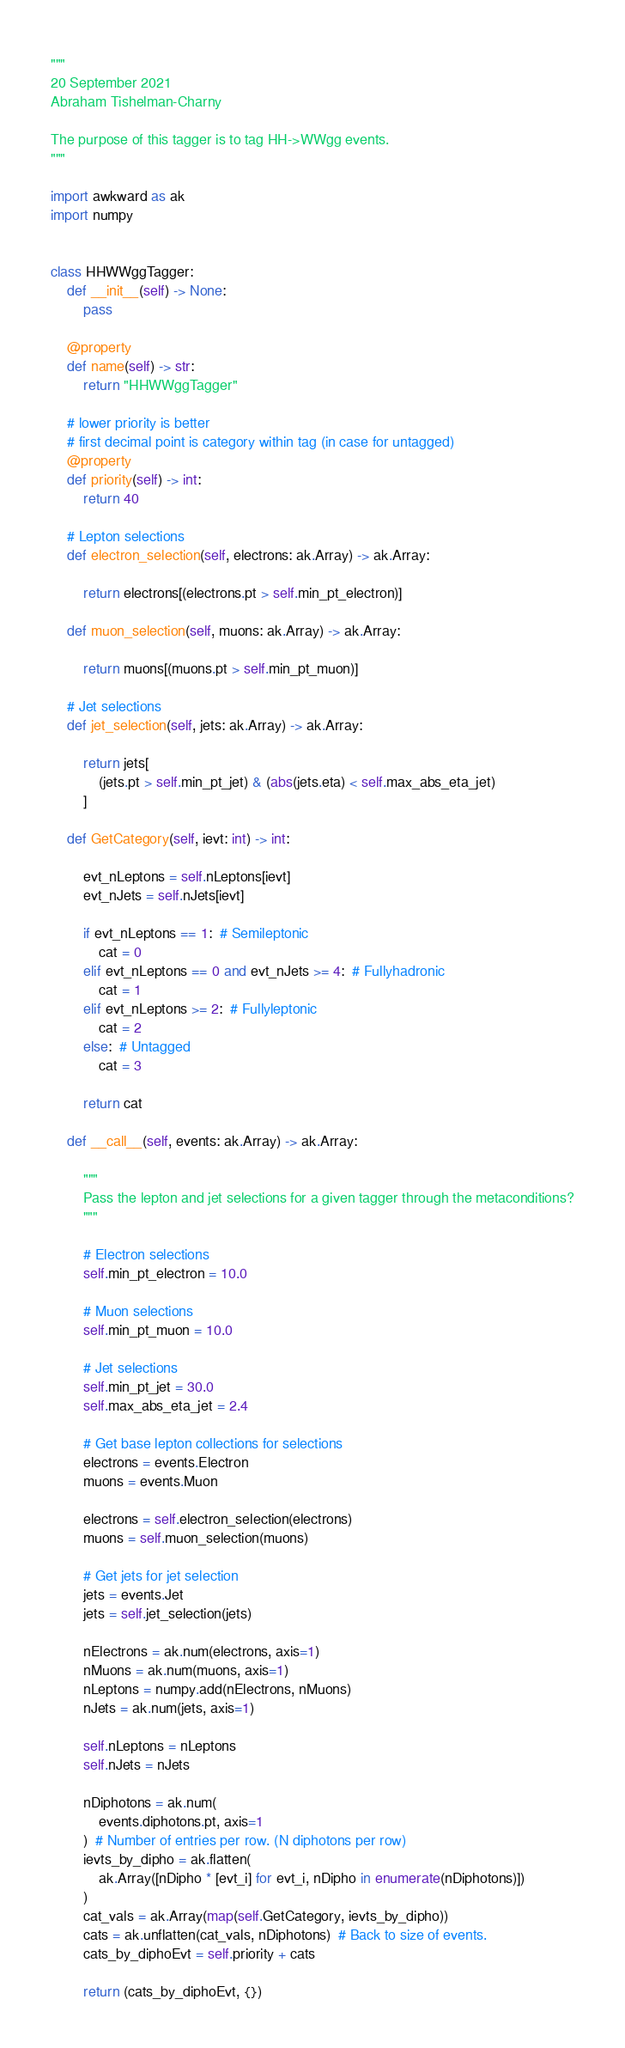Convert code to text. <code><loc_0><loc_0><loc_500><loc_500><_Python_>"""
20 September 2021
Abraham Tishelman-Charny

The purpose of this tagger is to tag HH->WWgg events.
"""

import awkward as ak
import numpy


class HHWWggTagger:
    def __init__(self) -> None:
        pass

    @property
    def name(self) -> str:
        return "HHWWggTagger"

    # lower priority is better
    # first decimal point is category within tag (in case for untagged)
    @property
    def priority(self) -> int:
        return 40

    # Lepton selections
    def electron_selection(self, electrons: ak.Array) -> ak.Array:

        return electrons[(electrons.pt > self.min_pt_electron)]

    def muon_selection(self, muons: ak.Array) -> ak.Array:

        return muons[(muons.pt > self.min_pt_muon)]

    # Jet selections
    def jet_selection(self, jets: ak.Array) -> ak.Array:

        return jets[
            (jets.pt > self.min_pt_jet) & (abs(jets.eta) < self.max_abs_eta_jet)
        ]

    def GetCategory(self, ievt: int) -> int:

        evt_nLeptons = self.nLeptons[ievt]
        evt_nJets = self.nJets[ievt]

        if evt_nLeptons == 1:  # Semileptonic
            cat = 0
        elif evt_nLeptons == 0 and evt_nJets >= 4:  # Fullyhadronic
            cat = 1
        elif evt_nLeptons >= 2:  # Fullyleptonic
            cat = 2
        else:  # Untagged
            cat = 3

        return cat

    def __call__(self, events: ak.Array) -> ak.Array:

        """
        Pass the lepton and jet selections for a given tagger through the metaconditions?
        """

        # Electron selections
        self.min_pt_electron = 10.0

        # Muon selections
        self.min_pt_muon = 10.0

        # Jet selections
        self.min_pt_jet = 30.0
        self.max_abs_eta_jet = 2.4

        # Get base lepton collections for selections
        electrons = events.Electron
        muons = events.Muon

        electrons = self.electron_selection(electrons)
        muons = self.muon_selection(muons)

        # Get jets for jet selection
        jets = events.Jet
        jets = self.jet_selection(jets)

        nElectrons = ak.num(electrons, axis=1)
        nMuons = ak.num(muons, axis=1)
        nLeptons = numpy.add(nElectrons, nMuons)
        nJets = ak.num(jets, axis=1)

        self.nLeptons = nLeptons
        self.nJets = nJets

        nDiphotons = ak.num(
            events.diphotons.pt, axis=1
        )  # Number of entries per row. (N diphotons per row)
        ievts_by_dipho = ak.flatten(
            ak.Array([nDipho * [evt_i] for evt_i, nDipho in enumerate(nDiphotons)])
        )
        cat_vals = ak.Array(map(self.GetCategory, ievts_by_dipho))
        cats = ak.unflatten(cat_vals, nDiphotons)  # Back to size of events.
        cats_by_diphoEvt = self.priority + cats

        return (cats_by_diphoEvt, {})
</code> 